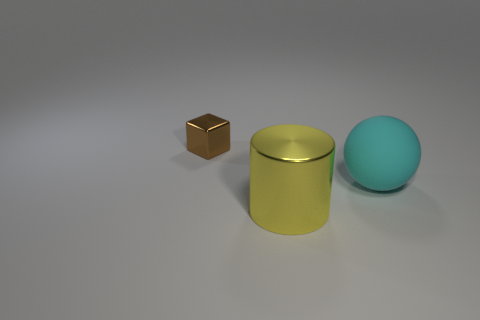Subtract all cylinders. How many objects are left? 2 Add 2 brown blocks. How many objects exist? 5 Add 2 metallic blocks. How many metallic blocks exist? 3 Subtract 0 red blocks. How many objects are left? 3 Subtract all big purple cubes. Subtract all big cyan spheres. How many objects are left? 2 Add 1 metal cylinders. How many metal cylinders are left? 2 